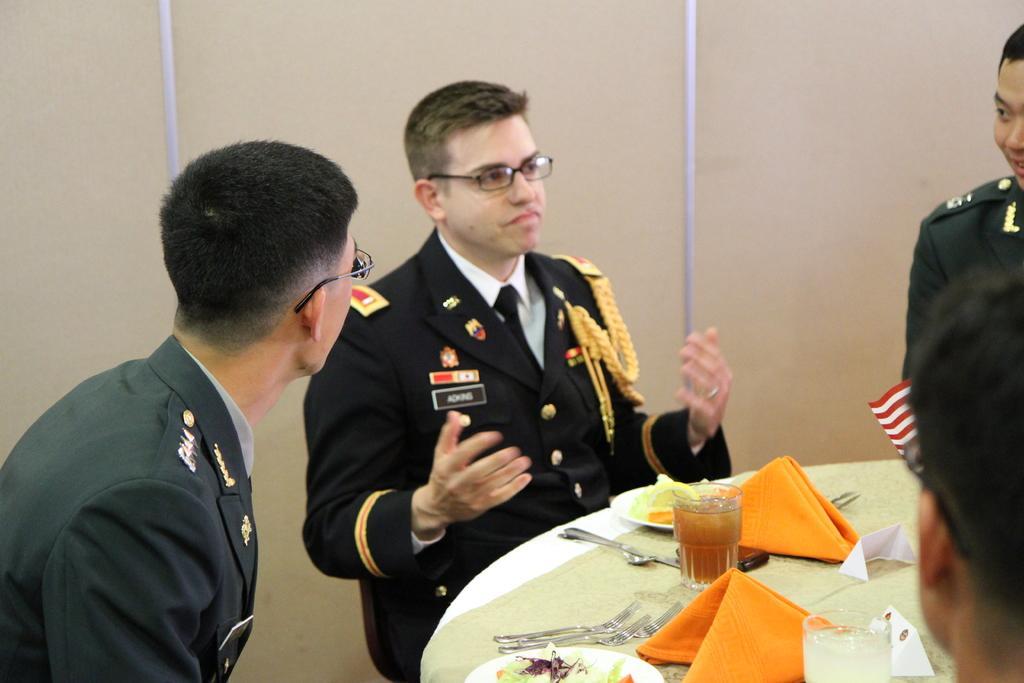How would you summarize this image in a sentence or two? In the image we can see there are people wearing clothes and they are sitting. These two people are wearing spectacles. In front of them there is a table, on the table, we can see glass, forks, spoons, napkins, plates and food on a plate. Here we can see a wall.  